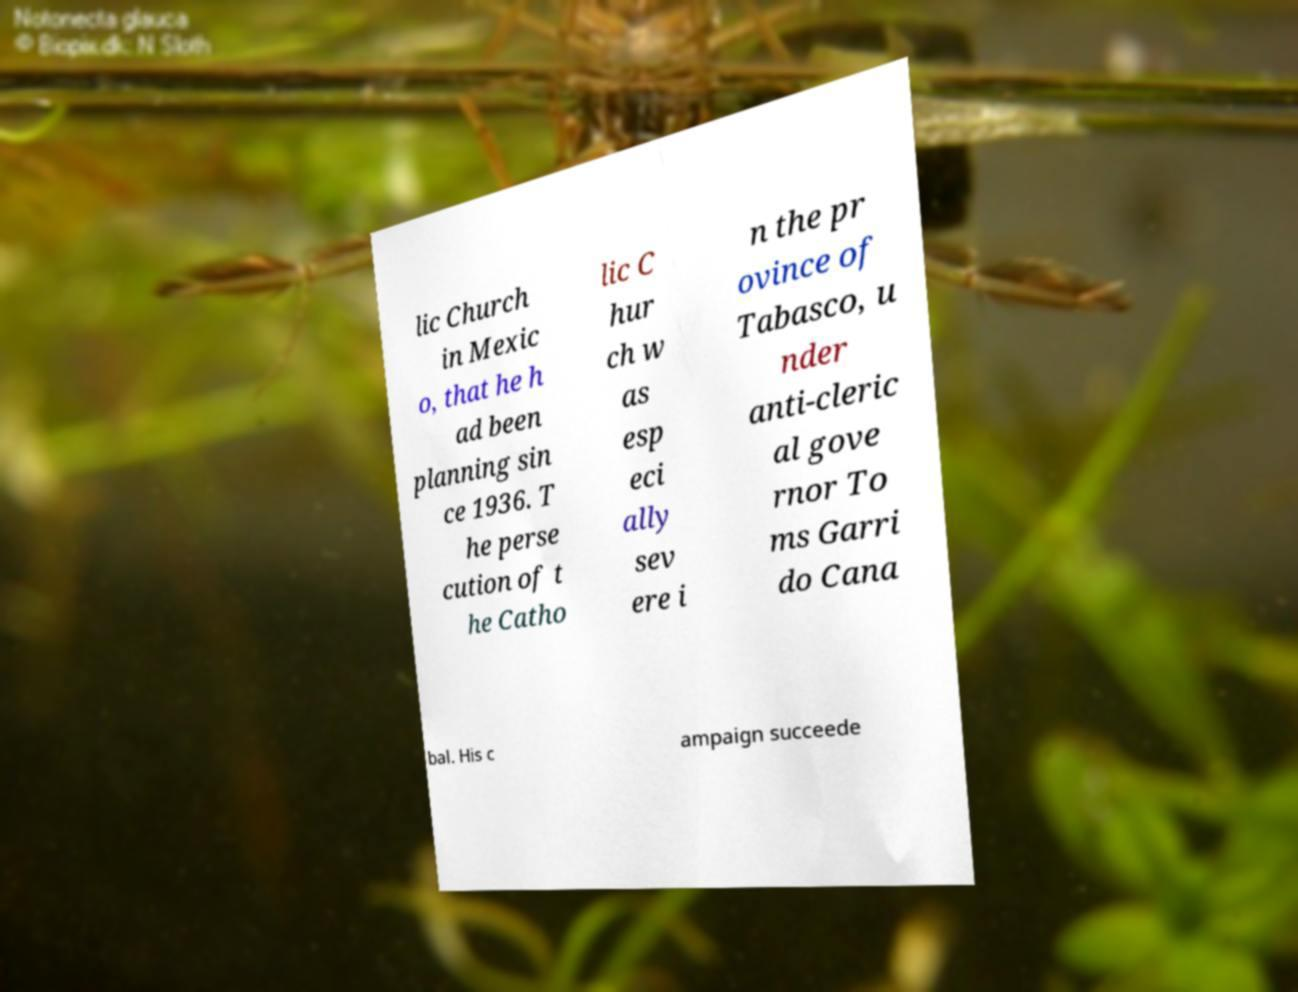For documentation purposes, I need the text within this image transcribed. Could you provide that? lic Church in Mexic o, that he h ad been planning sin ce 1936. T he perse cution of t he Catho lic C hur ch w as esp eci ally sev ere i n the pr ovince of Tabasco, u nder anti-cleric al gove rnor To ms Garri do Cana bal. His c ampaign succeede 